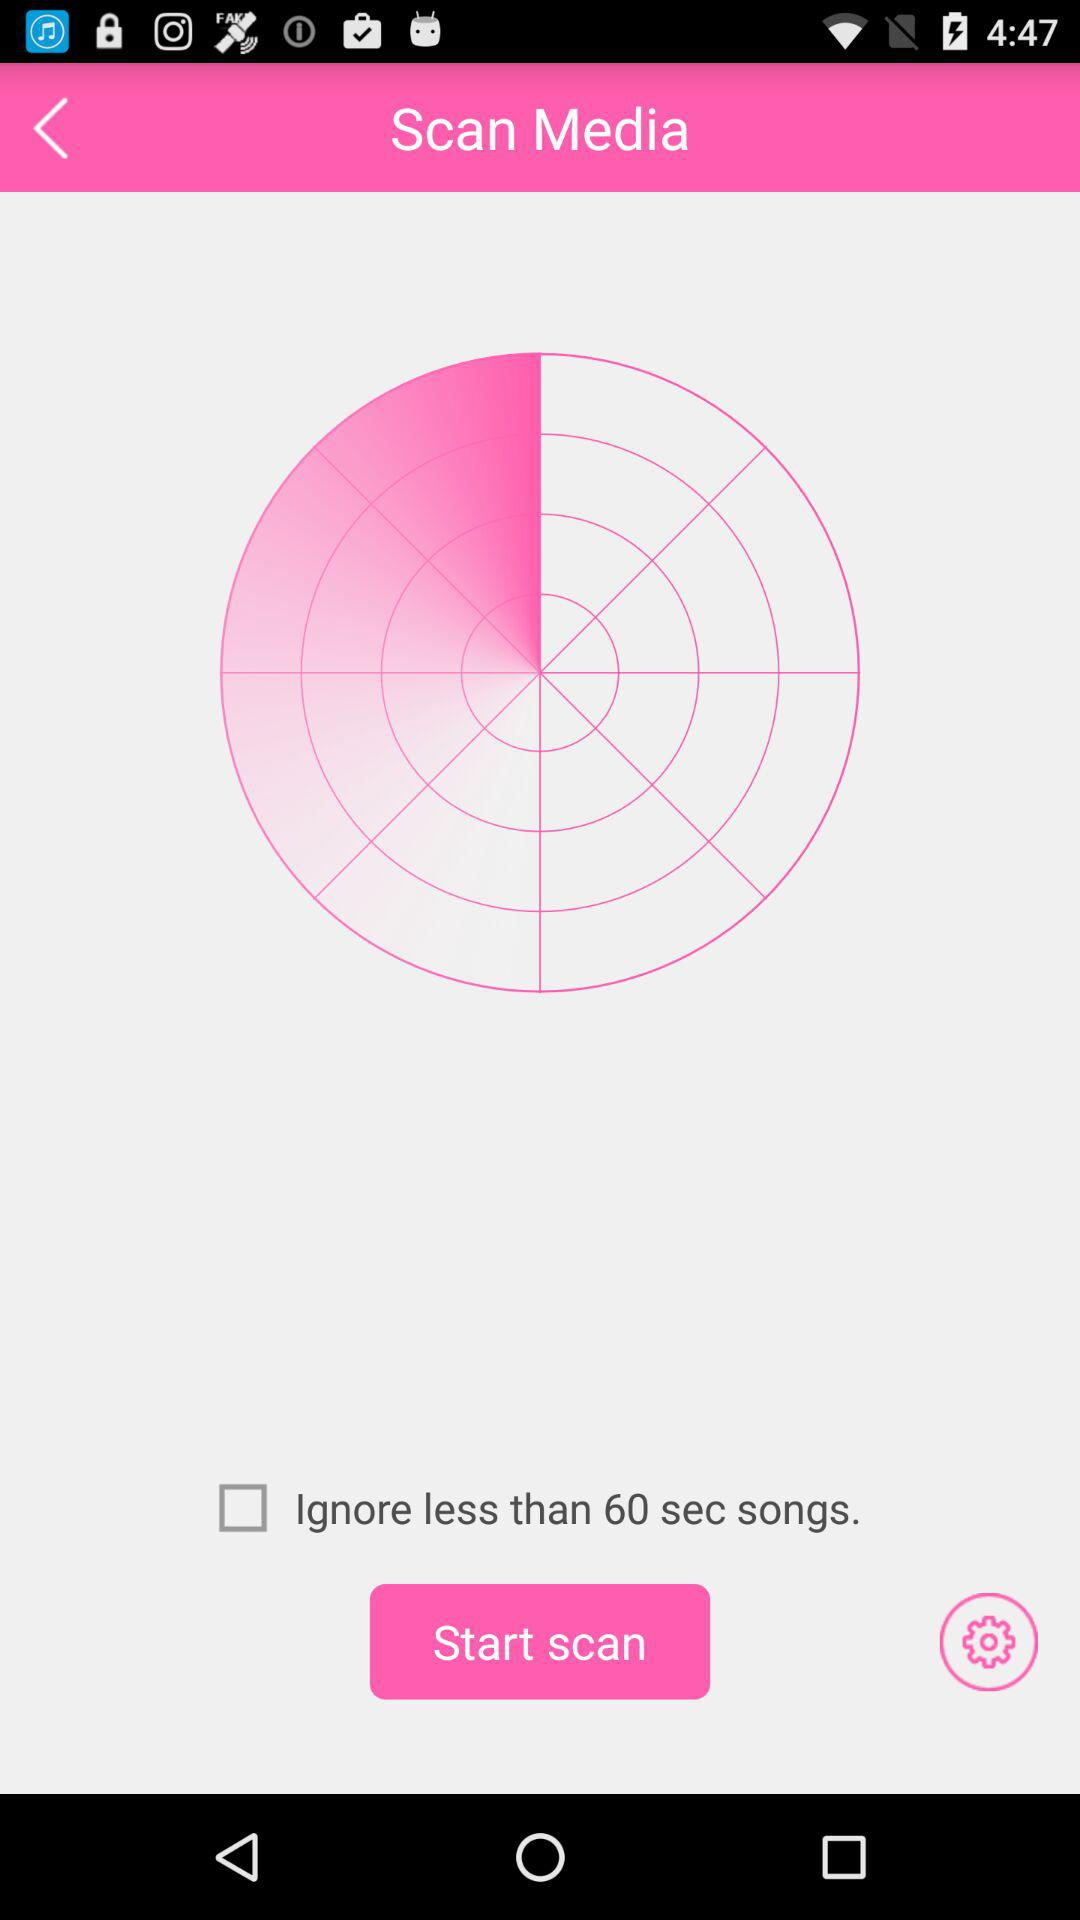What is the status of "Ignore less than 60 sec songs"? The status of "Ignore less than 60 sec songs" is "off". 